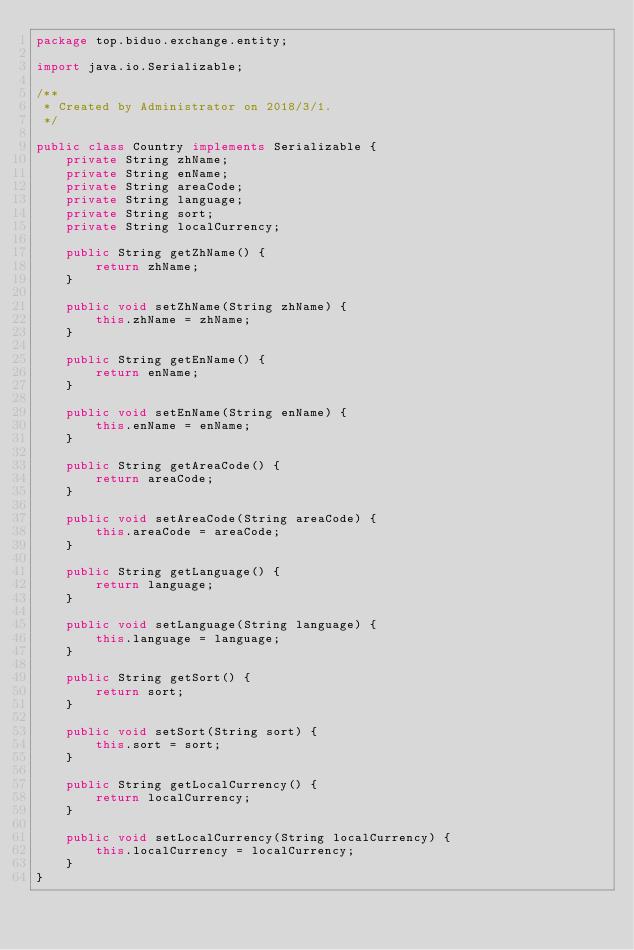Convert code to text. <code><loc_0><loc_0><loc_500><loc_500><_Java_>package top.biduo.exchange.entity;

import java.io.Serializable;

/**
 * Created by Administrator on 2018/3/1.
 */

public class Country implements Serializable {
    private String zhName;
    private String enName;
    private String areaCode;
    private String language;
    private String sort;
    private String localCurrency;

    public String getZhName() {
        return zhName;
    }

    public void setZhName(String zhName) {
        this.zhName = zhName;
    }

    public String getEnName() {
        return enName;
    }

    public void setEnName(String enName) {
        this.enName = enName;
    }

    public String getAreaCode() {
        return areaCode;
    }

    public void setAreaCode(String areaCode) {
        this.areaCode = areaCode;
    }

    public String getLanguage() {
        return language;
    }

    public void setLanguage(String language) {
        this.language = language;
    }

    public String getSort() {
        return sort;
    }

    public void setSort(String sort) {
        this.sort = sort;
    }

    public String getLocalCurrency() {
        return localCurrency;
    }

    public void setLocalCurrency(String localCurrency) {
        this.localCurrency = localCurrency;
    }
}
</code> 